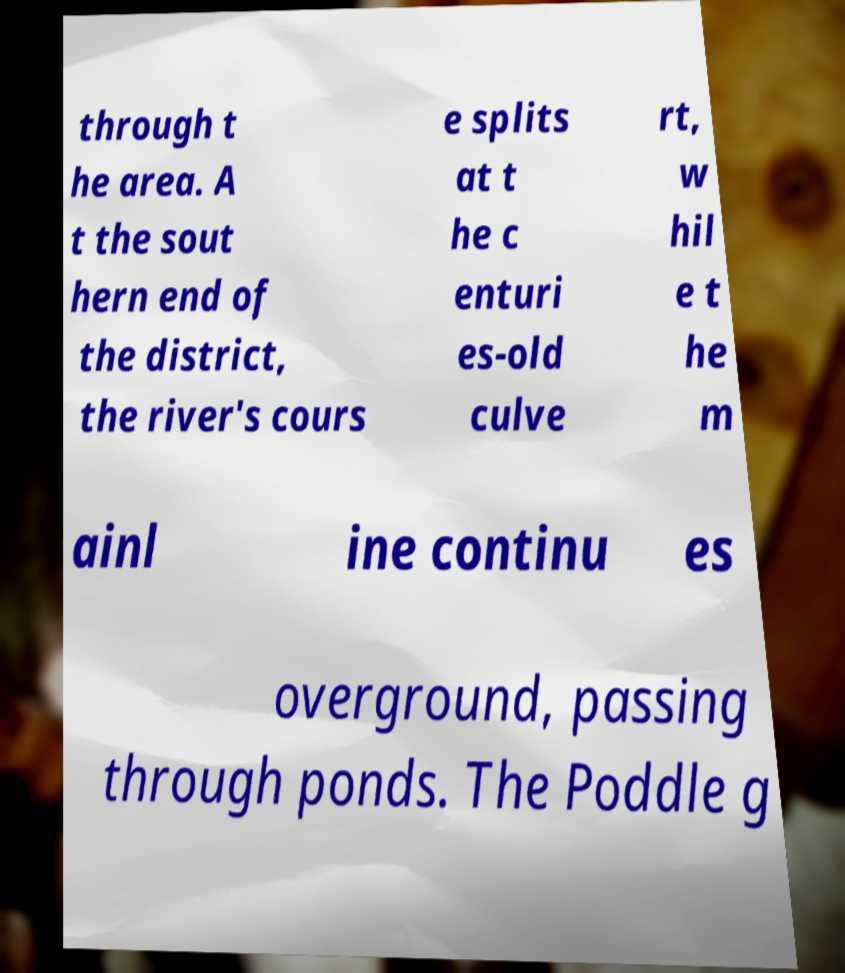Could you extract and type out the text from this image? through t he area. A t the sout hern end of the district, the river's cours e splits at t he c enturi es-old culve rt, w hil e t he m ainl ine continu es overground, passing through ponds. The Poddle g 